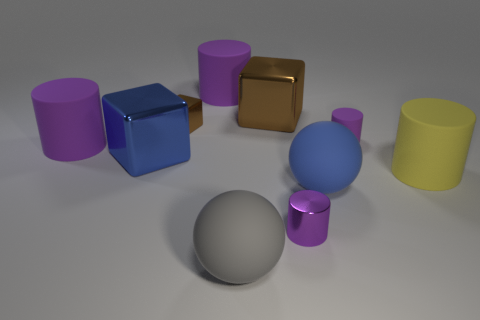Can you discuss the lighting and shadows seen in the image? In the image, the lighting appears to be coming from the upper left, as indicated by the shadows cast towards the right. Each object casts a soft-edged shadow, demonstrating a light source that is not extremely close. This type of shadow suggests a softly diffused light rather than a harsh, direct spotlight. The objects' surfaces have highlights and reflections that conform to their shapes, contributing to the perception of depth and dimension in the scene. 